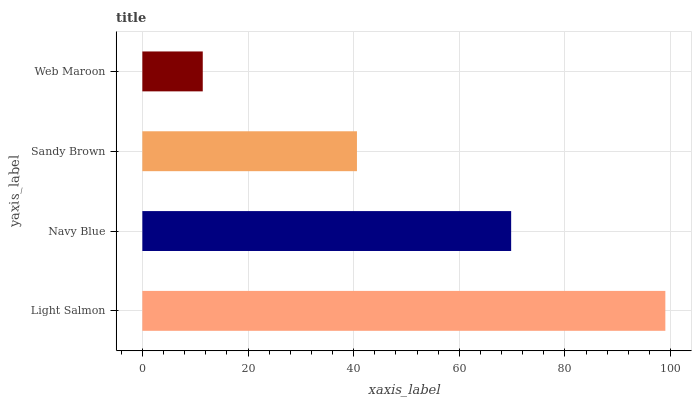Is Web Maroon the minimum?
Answer yes or no. Yes. Is Light Salmon the maximum?
Answer yes or no. Yes. Is Navy Blue the minimum?
Answer yes or no. No. Is Navy Blue the maximum?
Answer yes or no. No. Is Light Salmon greater than Navy Blue?
Answer yes or no. Yes. Is Navy Blue less than Light Salmon?
Answer yes or no. Yes. Is Navy Blue greater than Light Salmon?
Answer yes or no. No. Is Light Salmon less than Navy Blue?
Answer yes or no. No. Is Navy Blue the high median?
Answer yes or no. Yes. Is Sandy Brown the low median?
Answer yes or no. Yes. Is Sandy Brown the high median?
Answer yes or no. No. Is Navy Blue the low median?
Answer yes or no. No. 